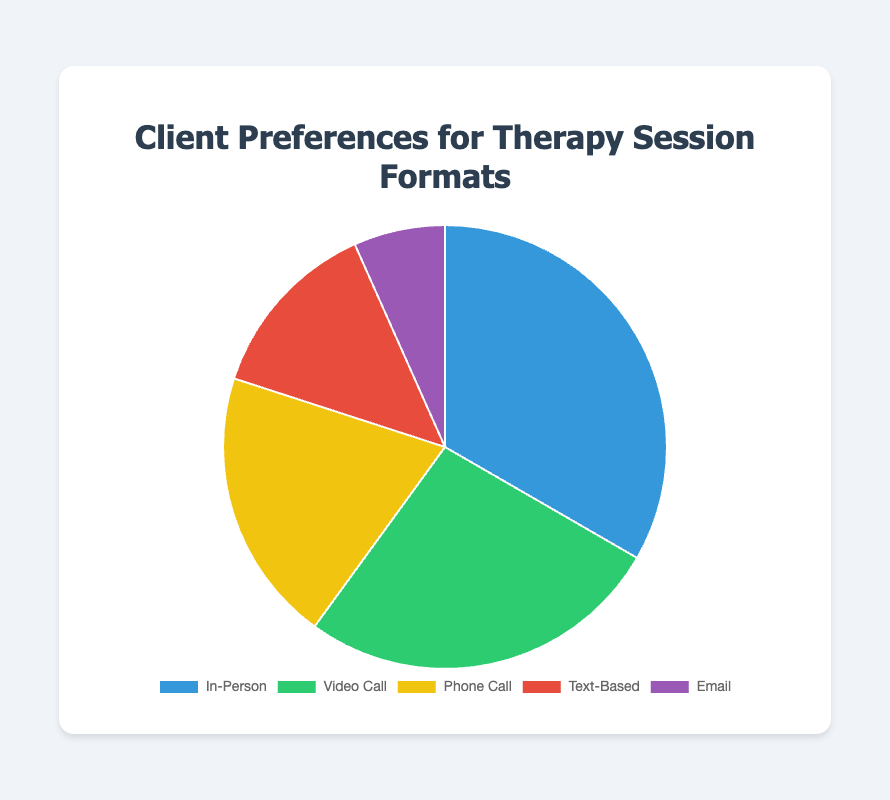Which session format do most clients prefer? The largest section of the pie chart corresponds to the "In-Person" session format, indicating that it has the highest number of clients.
Answer: In-Person Which session format has the fewest clients? The smallest section of the pie chart corresponds to the "Email" session format, indicating that it has the lowest number of clients.
Answer: Email How many more clients prefer Video Call sessions compared to Phone Call sessions? The number of clients for Video Call sessions is 120, and for Phone Call sessions is 90. The difference is 120 - 90.
Answer: 30 Are there more clients who prefer Text-Based sessions or Email sessions? Comparing the two sections, the Text-Based portion is larger than the Email portion.
Answer: Text-Based What is the total number of clients represented in the pie chart? Add the number of clients from all session formats: 150 (In-Person) + 120 (Video Call) + 90 (Phone Call) + 60 (Text-Based) + 30 (Email) = 450.
Answer: 450 Which session format constitutes the second largest group of clients? The second largest section of the pie chart corresponds to the "Video Call" session format, which is smaller than "In-Person" but larger than the others.
Answer: Video Call How many clients prefer either Phone Call or Email sessions? The number of clients for Phone Call sessions is 90, and for Email sessions is 30. Their sum is 90 + 30.
Answer: 120 Is the difference in the number of clients who prefer In-Person vs. Video Call sessions greater than the difference between Phone Call and Text-Based sessions? The difference between In-Person and Video Call is 150 - 120 = 30. The difference between Phone Call and Text-Based is 90 - 60 = 30. Since both differences are 30, they are equal.
Answer: No What percentage of the total clients prefer In-Person sessions? The number of clients for In-Person sessions is 150, and the total number of clients is 450. The percentage is (150 / 450) * 100.
Answer: 33.33% Which session format is represented in green in the pie chart? By looking at the color distribution of the pie chart, the green section corresponds to "Video Call".
Answer: Video Call 